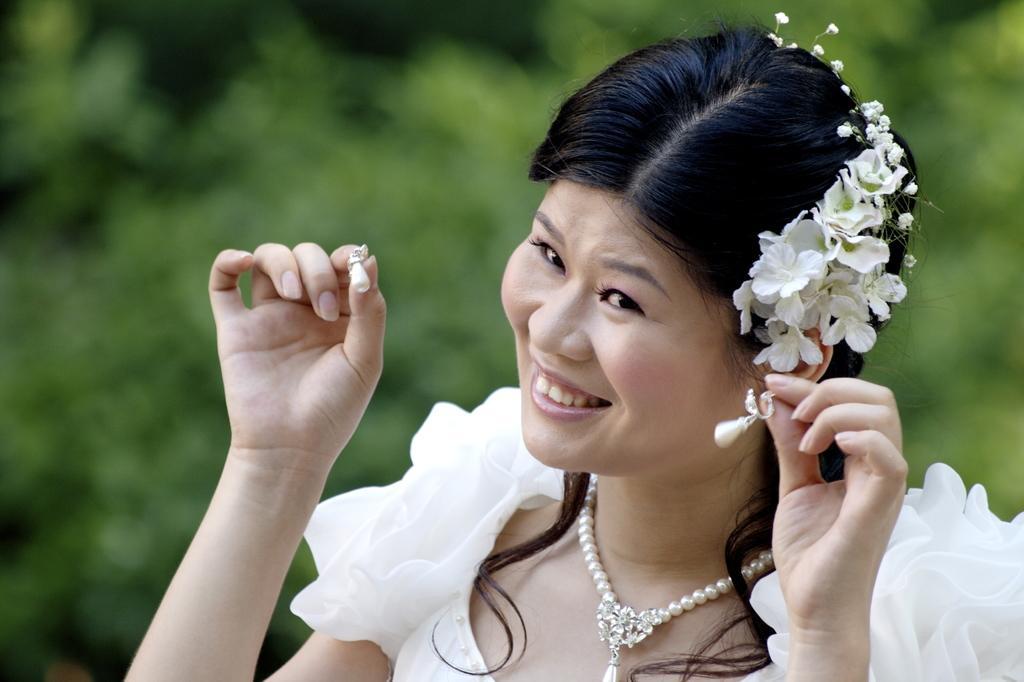Can you describe this image briefly? In this image in the foreground there is one woman who is smiling, and in the background there are some trees. 